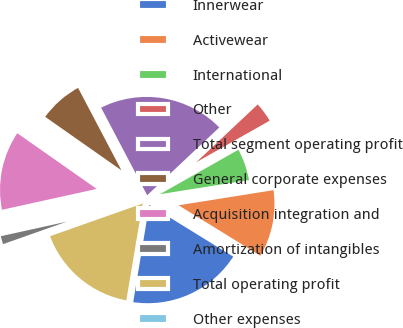Convert chart to OTSL. <chart><loc_0><loc_0><loc_500><loc_500><pie_chart><fcel>Innerwear<fcel>Activewear<fcel>International<fcel>Other<fcel>Total segment operating profit<fcel>General corporate expenses<fcel>Acquisition integration and<fcel>Amortization of intangibles<fcel>Total operating profit<fcel>Other expenses<nl><fcel>18.81%<fcel>11.31%<fcel>5.69%<fcel>3.81%<fcel>20.69%<fcel>7.56%<fcel>13.19%<fcel>1.94%<fcel>16.94%<fcel>0.06%<nl></chart> 